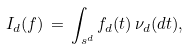<formula> <loc_0><loc_0><loc_500><loc_500>I _ { d } ( f ) \, = \, \int _ { \real s ^ { d } } f _ { d } ( t ) \, \nu _ { d } ( d t ) ,</formula> 